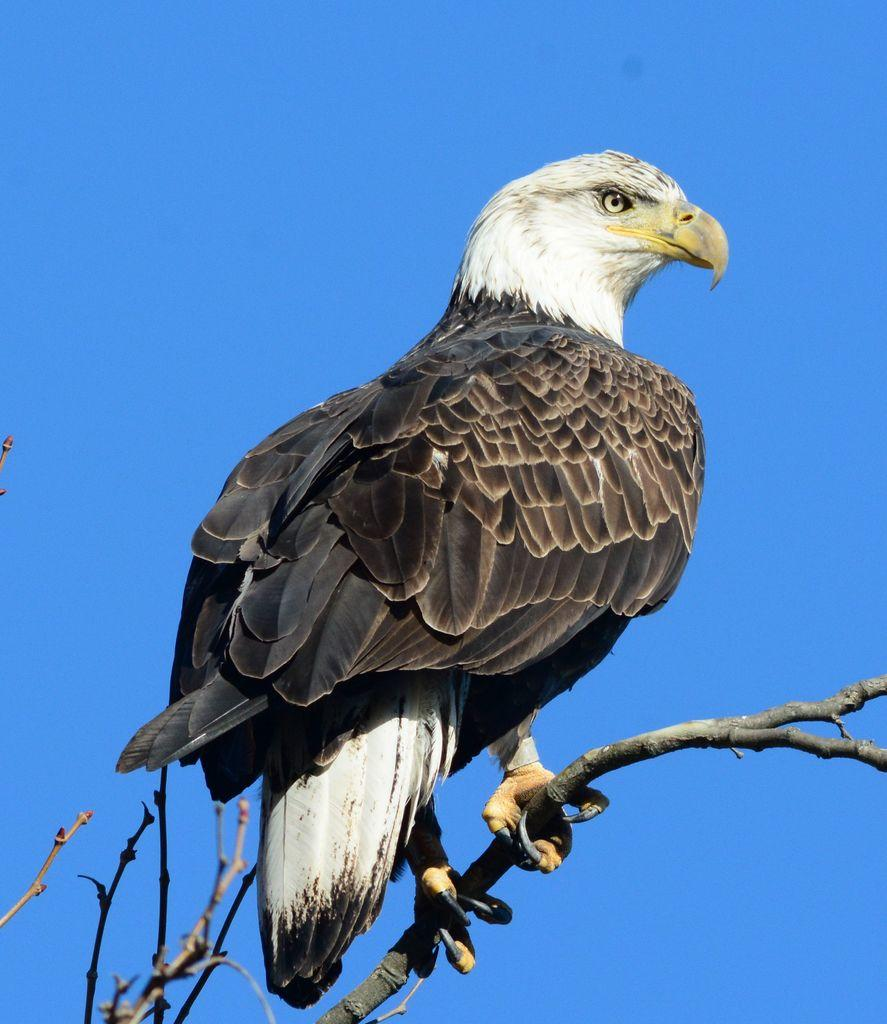What animal is the main subject of the picture? There is an eagle in the picture. Where is the eagle located in the image? The eagle is sitting on a tree stem. What color are the eagle's feathers? The eagle has black feathers. What color is the eagle's beak? The eagle has a yellow beak. What is the condition of the sky in the picture? The sky is clear in the picture. How many geese are flying in formation with the eagle in the image? There are no geese present in the image; it features an eagle sitting on a tree stem. What type of hands does the eagle have in the image? Eagles do not have hands; they have wings and talons. 